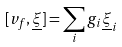Convert formula to latex. <formula><loc_0><loc_0><loc_500><loc_500>[ v _ { f } , \underline { \xi } ] = \sum _ { i } g _ { i } \underline { \xi } _ { i }</formula> 